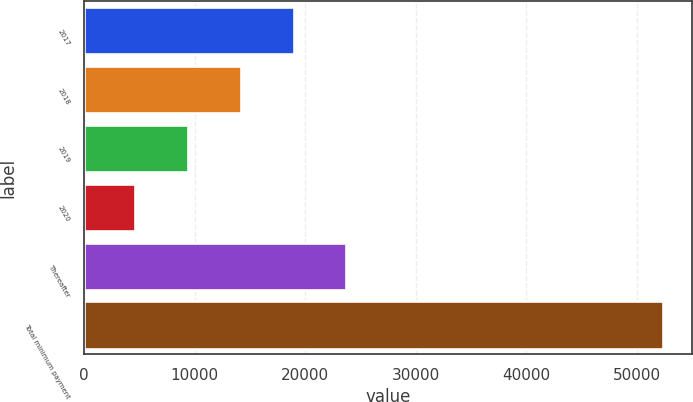Convert chart to OTSL. <chart><loc_0><loc_0><loc_500><loc_500><bar_chart><fcel>2017<fcel>2018<fcel>2019<fcel>2020<fcel>Thereafter<fcel>Total minimum payment<nl><fcel>18945.2<fcel>14172.8<fcel>9400.4<fcel>4628<fcel>23717.6<fcel>52352<nl></chart> 